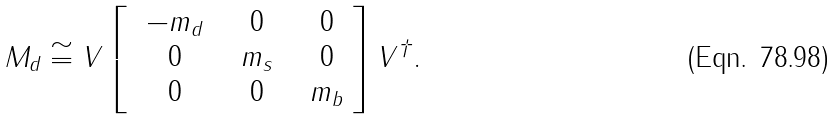<formula> <loc_0><loc_0><loc_500><loc_500>M _ { d } \cong V \left [ \begin{array} { c c c } { { \ - m _ { d } \ } } & { \ 0 \ } & { \ 0 } \\ { \ 0 \ } & { { \ m _ { s } \ } } & { \ 0 } \\ { \ 0 \ } & { \ 0 \ } & { { \ m _ { b } } } \end{array} \right ] V ^ { \dagger } .</formula> 